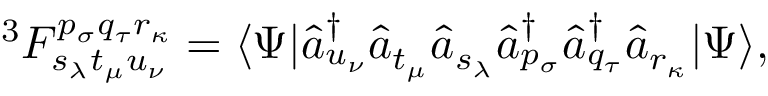Convert formula to latex. <formula><loc_0><loc_0><loc_500><loc_500>^ { 3 } F _ { s _ { \lambda } t _ { \mu } u _ { \nu } } ^ { p _ { \sigma } q _ { \tau } r _ { \kappa } } = \langle \Psi | \hat { a } _ { u _ { \nu } } ^ { \dagger } \hat { a } _ { t _ { \mu } } \hat { a } _ { s _ { \lambda } } \hat { a } _ { p _ { \sigma } } ^ { \dagger } \hat { a } _ { q _ { \tau } } ^ { \dagger } \hat { a } _ { r _ { \kappa } } | \Psi \rangle ,</formula> 